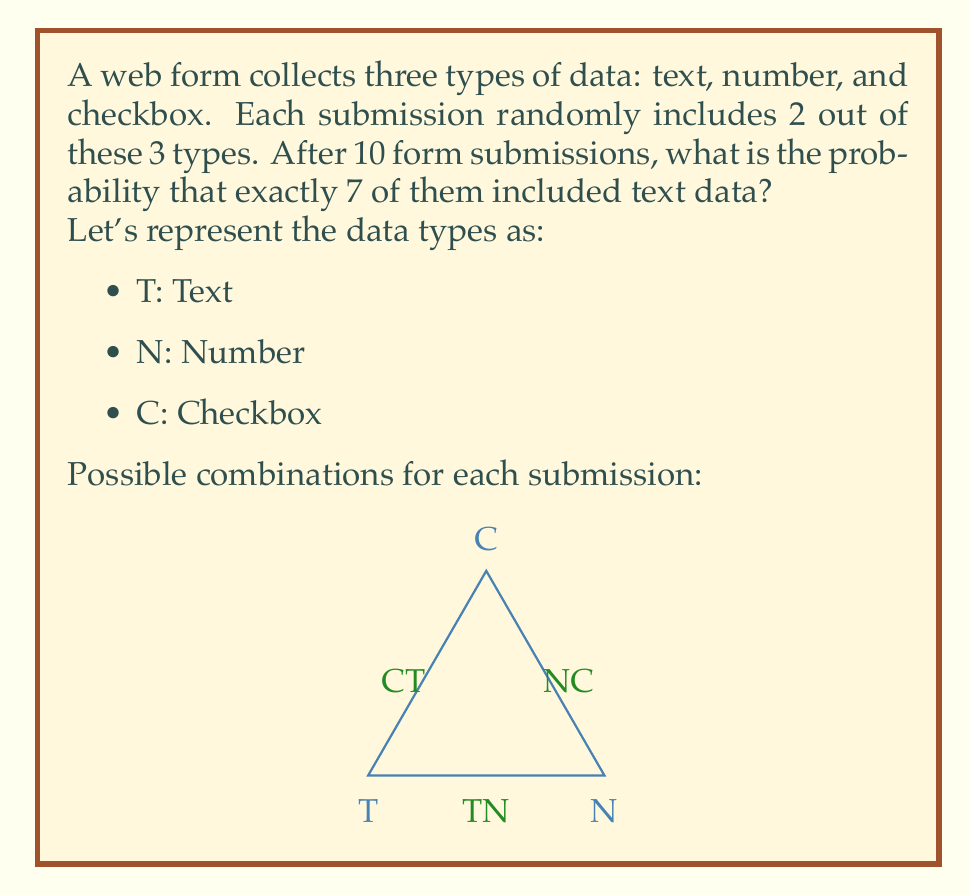What is the answer to this math problem? Let's approach this step-by-step:

1) First, we need to calculate the probability of a single submission including text data.
   There are 3 possible combinations: TN, NC, CT
   2 out of these 3 combinations include text (TN and CT)
   So, probability of text in a single submission = $\frac{2}{3}$

2) Now, we can model this as a binomial probability problem.
   We want exactly 7 successes (text inclusions) out of 10 trials (submissions).

3) The binomial probability formula is:
   $$P(X = k) = \binom{n}{k} p^k (1-p)^{n-k}$$
   Where:
   $n$ = number of trials = 10
   $k$ = number of successes = 7
   $p$ = probability of success on each trial = $\frac{2}{3}$

4) Let's substitute these values:
   $$P(X = 7) = \binom{10}{7} (\frac{2}{3})^7 (1-\frac{2}{3})^{10-7}$$

5) Simplify:
   $$P(X = 7) = \binom{10}{7} (\frac{2}{3})^7 (\frac{1}{3})^3$$

6) Calculate:
   $$P(X = 7) = 120 \cdot (\frac{2}{3})^7 \cdot (\frac{1}{3})^3$$
   $$P(X = 7) = 120 \cdot \frac{128}{2187} \cdot \frac{1}{27} \approx 0.2585$$

Therefore, the probability is approximately 0.2585 or about 25.85%.
Answer: $\frac{120 \cdot 128}{2187 \cdot 27} \approx 0.2585$ 